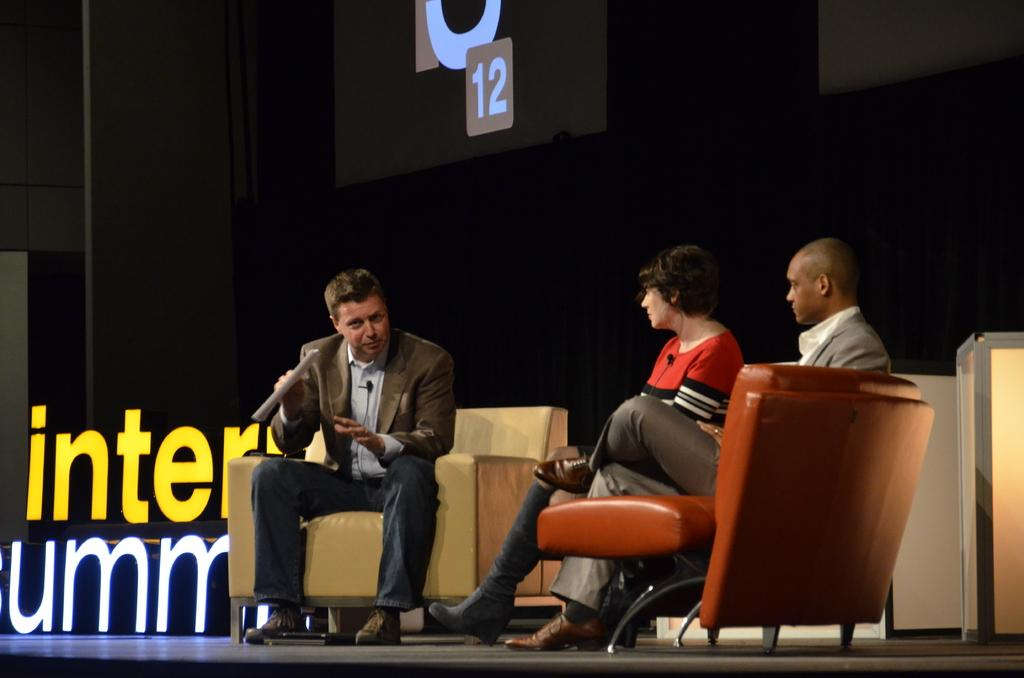How many people are in the image? There are three persons in the image. What are the persons doing in the image? The three persons are sitting on a sofa. Can you describe the arrangement of the persons on the sofa? Two of the persons are on the right side of the sofa, and one person is on the left side of the sofa. What type of advice can be heard from the bears in the image? There are no bears present in the image, so no advice can be heard from them. 